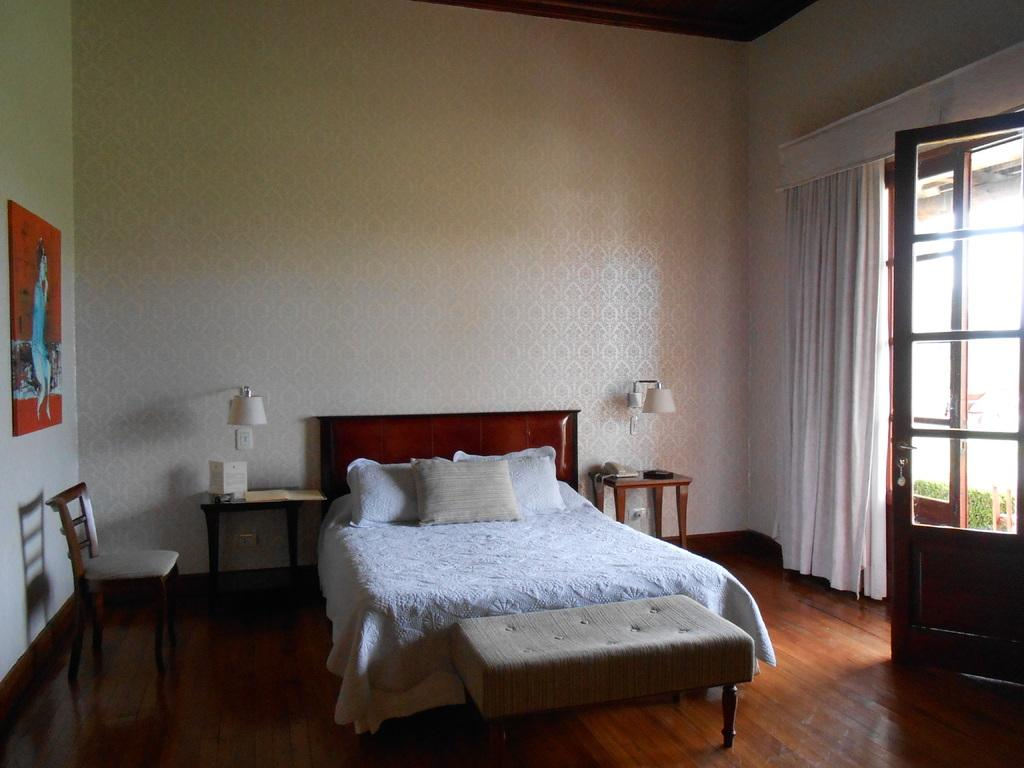What type of furniture is present in the image? There is a bed, a chair, and tables in the image. What can be found on the bed? The bed has pillows on it. What type of lighting is present in the image? There are lamps in the image. What communication device is visible in the image? There is a telephone in the image. What type of access point is present in the image? There is a door in the image. What type of window treatment is present in the image? There are curtains in the image. What type of decoration is present on the wall in the image? There is a frame on the wall in the image. What type of lipstick is visible on the page in the image? There is no lipstick or page present in the image. What type of house is shown in the image? The image does not depict a house; it shows a room with furniture and decorations. 